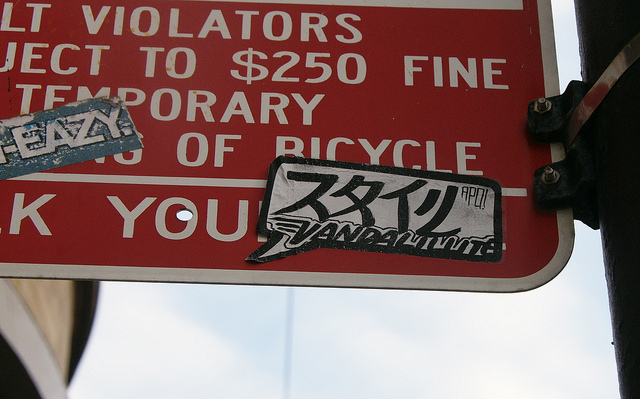Please extract the text content from this image. VIOLATORS TO 250 OF FINE VANDALILLITE APO! K YOU RICYCLE EAZY TEMPORARY JECT LT $ 